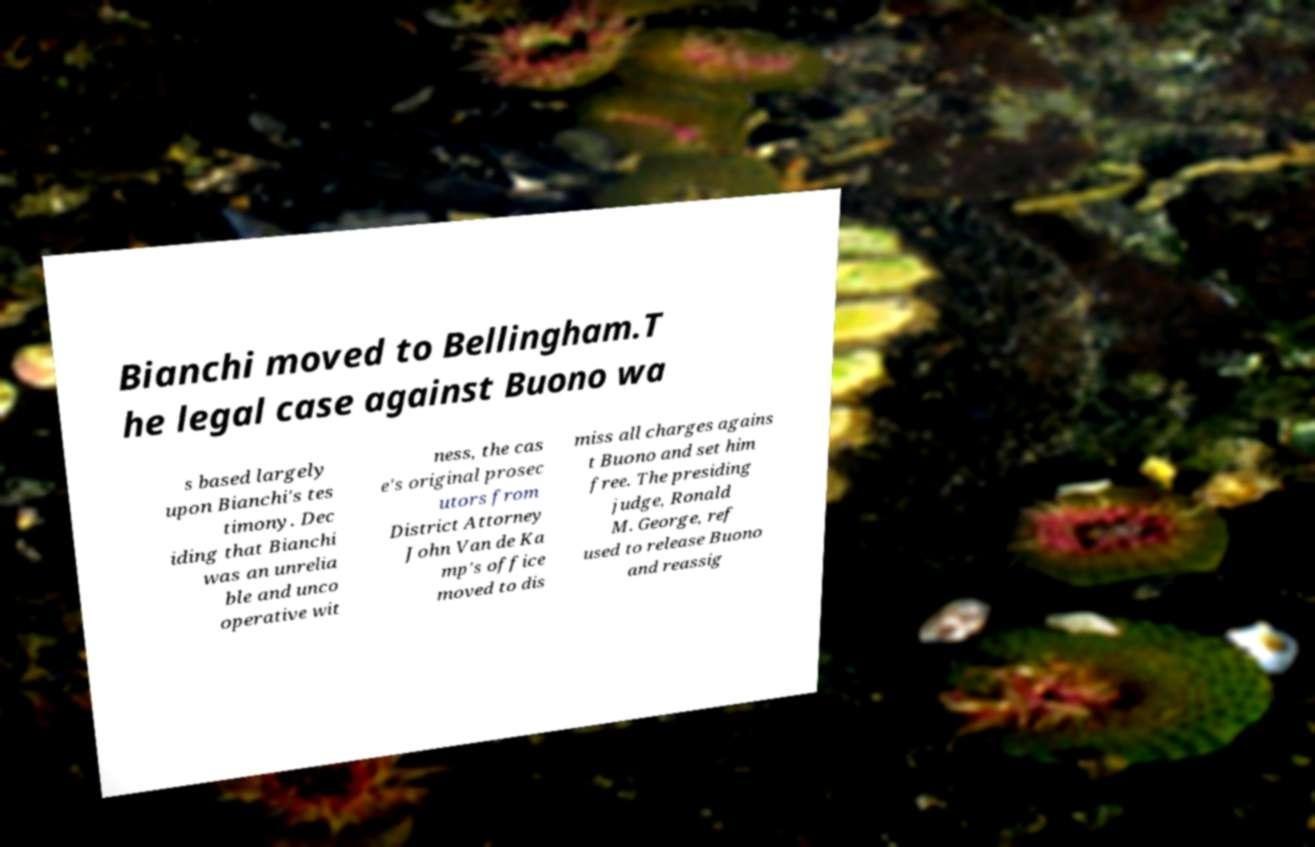There's text embedded in this image that I need extracted. Can you transcribe it verbatim? Bianchi moved to Bellingham.T he legal case against Buono wa s based largely upon Bianchi's tes timony. Dec iding that Bianchi was an unrelia ble and unco operative wit ness, the cas e's original prosec utors from District Attorney John Van de Ka mp's office moved to dis miss all charges agains t Buono and set him free. The presiding judge, Ronald M. George, ref used to release Buono and reassig 